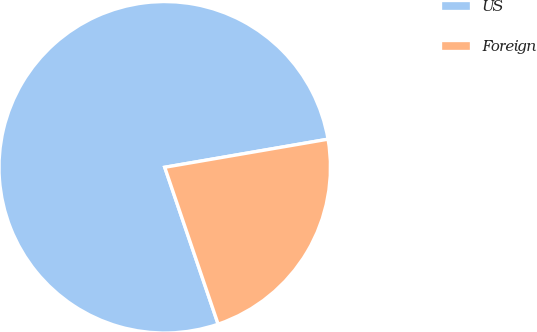<chart> <loc_0><loc_0><loc_500><loc_500><pie_chart><fcel>US<fcel>Foreign<nl><fcel>77.51%<fcel>22.49%<nl></chart> 